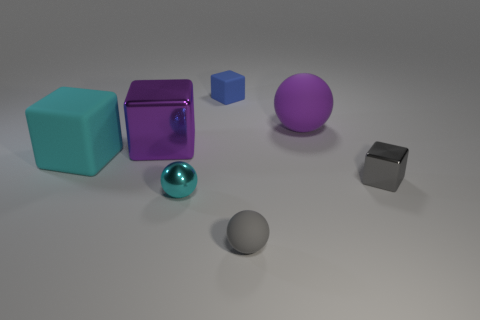How many other cyan metallic things are the same shape as the tiny cyan thing?
Keep it short and to the point. 0. There is a tiny thing that is both in front of the gray metal block and behind the small rubber sphere; what is it made of?
Make the answer very short. Metal. Do the large purple sphere and the large purple cube have the same material?
Offer a very short reply. No. What number of gray spheres are there?
Offer a very short reply. 1. There is a matte sphere in front of the small gray thing on the right side of the big thing that is on the right side of the blue block; what is its color?
Offer a terse response. Gray. Is the color of the big metal object the same as the large matte ball?
Your answer should be compact. Yes. How many tiny objects are in front of the purple ball and behind the purple matte sphere?
Your answer should be compact. 0. How many metal objects are tiny blue things or large red cylinders?
Make the answer very short. 0. There is a tiny object right of the small rubber object that is in front of the gray metal block; what is its material?
Make the answer very short. Metal. There is a big matte object that is the same color as the large shiny cube; what shape is it?
Your answer should be very brief. Sphere. 